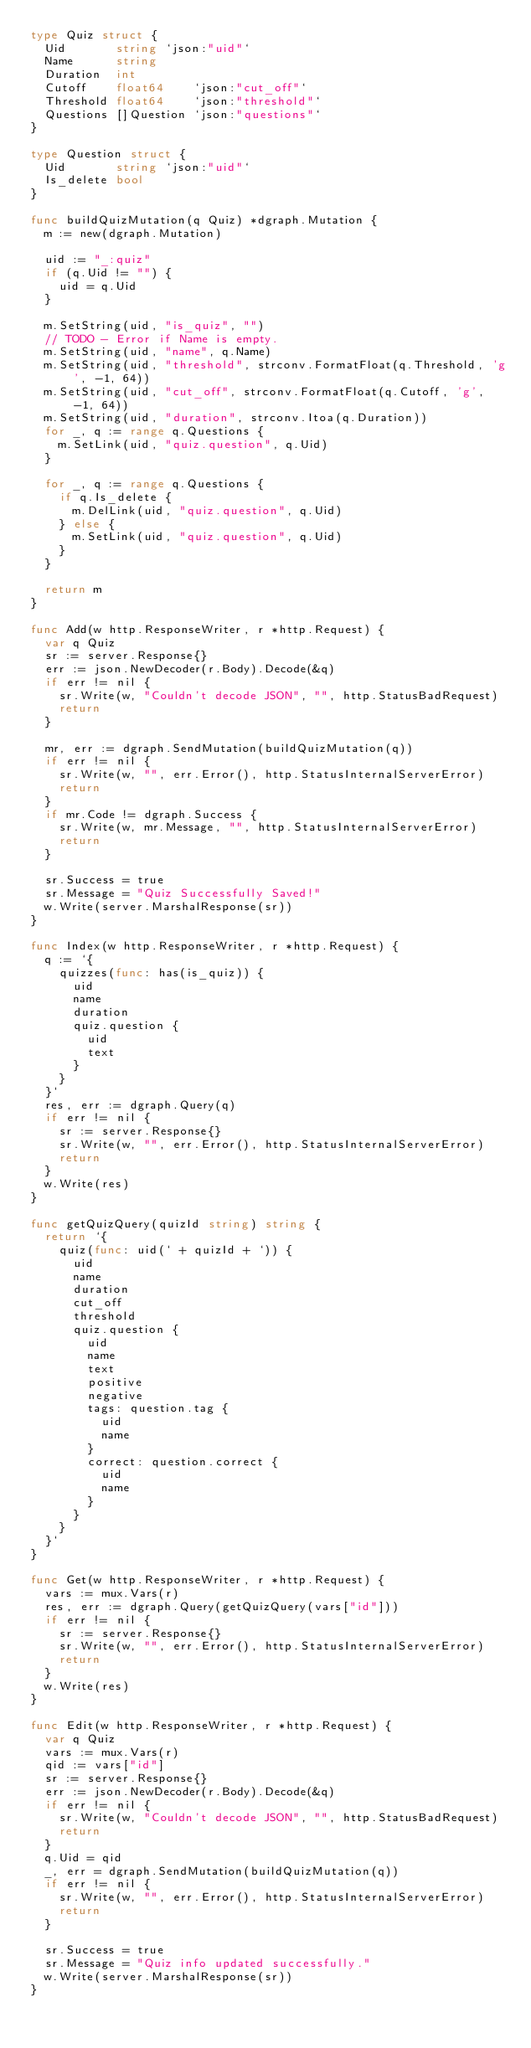<code> <loc_0><loc_0><loc_500><loc_500><_Go_>type Quiz struct {
	Uid       string `json:"uid"`
	Name      string
	Duration  int
	Cutoff    float64    `json:"cut_off"`
	Threshold float64    `json:"threshold"`
	Questions []Question `json:"questions"`
}

type Question struct {
	Uid       string `json:"uid"`
	Is_delete bool
}

func buildQuizMutation(q Quiz) *dgraph.Mutation {
	m := new(dgraph.Mutation)

	uid := "_:quiz"
	if (q.Uid != "") {
		uid = q.Uid
	}

	m.SetString(uid, "is_quiz", "")
	// TODO - Error if Name is empty.
	m.SetString(uid, "name", q.Name)
	m.SetString(uid, "threshold", strconv.FormatFloat(q.Threshold, 'g', -1, 64))
	m.SetString(uid, "cut_off", strconv.FormatFloat(q.Cutoff, 'g', -1, 64))
	m.SetString(uid, "duration", strconv.Itoa(q.Duration))
	for _, q := range q.Questions {
		m.SetLink(uid, "quiz.question", q.Uid)
	}

	for _, q := range q.Questions {
		if q.Is_delete {
			m.DelLink(uid, "quiz.question", q.Uid)
		} else {
			m.SetLink(uid, "quiz.question", q.Uid)
		}
	}

	return m
}

func Add(w http.ResponseWriter, r *http.Request) {
	var q Quiz
	sr := server.Response{}
	err := json.NewDecoder(r.Body).Decode(&q)
	if err != nil {
		sr.Write(w, "Couldn't decode JSON", "", http.StatusBadRequest)
		return
	}

	mr, err := dgraph.SendMutation(buildQuizMutation(q))
	if err != nil {
		sr.Write(w, "", err.Error(), http.StatusInternalServerError)
		return
	}
	if mr.Code != dgraph.Success {
		sr.Write(w, mr.Message, "", http.StatusInternalServerError)
		return
	}

	sr.Success = true
	sr.Message = "Quiz Successfully Saved!"
	w.Write(server.MarshalResponse(sr))
}

func Index(w http.ResponseWriter, r *http.Request) {
	q := `{
		quizzes(func: has(is_quiz)) {
			uid
			name
			duration
			quiz.question {
				uid
				text
			}
		}
	}`
	res, err := dgraph.Query(q)
	if err != nil {
		sr := server.Response{}
		sr.Write(w, "", err.Error(), http.StatusInternalServerError)
		return
	}
	w.Write(res)
}

func getQuizQuery(quizId string) string {
	return `{
		quiz(func: uid(` + quizId + `)) {
			uid
			name
			duration
			cut_off
			threshold
			quiz.question {
				uid
				name
				text
				positive
				negative
				tags: question.tag {
					uid
					name
				}
				correct: question.correct {
					uid
					name
				}
			}
		}
  }`
}

func Get(w http.ResponseWriter, r *http.Request) {
	vars := mux.Vars(r)
	res, err := dgraph.Query(getQuizQuery(vars["id"]))
	if err != nil {
		sr := server.Response{}
		sr.Write(w, "", err.Error(), http.StatusInternalServerError)
		return
	}
	w.Write(res)
}

func Edit(w http.ResponseWriter, r *http.Request) {
	var q Quiz
	vars := mux.Vars(r)
	qid := vars["id"]
	sr := server.Response{}
	err := json.NewDecoder(r.Body).Decode(&q)
	if err != nil {
		sr.Write(w, "Couldn't decode JSON", "", http.StatusBadRequest)
		return
	}
	q.Uid = qid
	_, err = dgraph.SendMutation(buildQuizMutation(q))
	if err != nil {
		sr.Write(w, "", err.Error(), http.StatusInternalServerError)
		return
	}

	sr.Success = true
	sr.Message = "Quiz info updated successfully."
	w.Write(server.MarshalResponse(sr))
}
</code> 